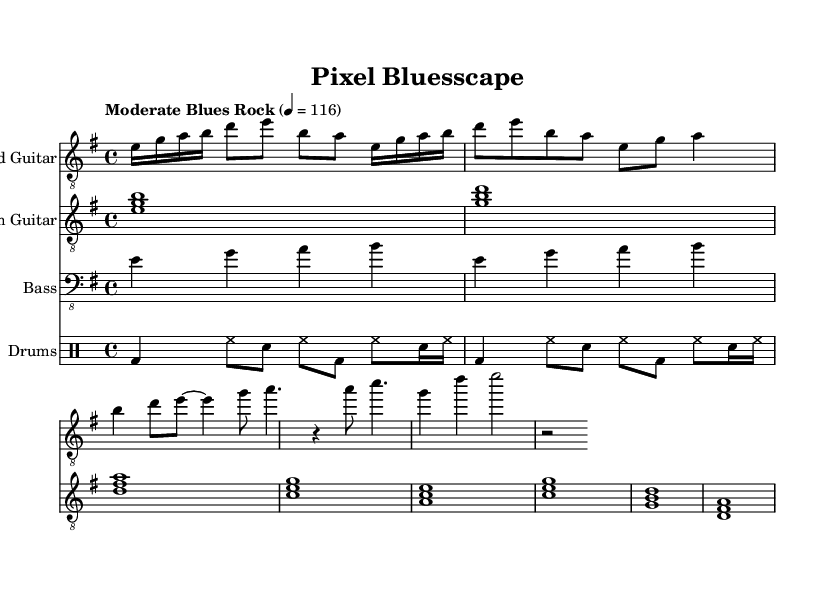What is the key signature of this music? The key signature indicates E minor, which contains one sharp (F#). This is determined by the absence of any flat notes in the staff and following the indicated key at the beginning.
Answer: E minor What is the time signature of this piece? The time signature shown is 4/4, which means there are four beats in a measure and the quarter note receives one beat. This is specified at the beginning of the score.
Answer: 4/4 What is the tempo marking of this composition? The tempo marking states "Moderate Blues Rock," and it indicates a setting of 116 beats per minute, which is noted as a tempo indication right under the global settings.
Answer: Moderate Blues Rock What type of guitar is featured as the lead instrument? The score shows that the clef designated is "treble_8," indicating that this section is for the lead guitar. This is labeled at the beginning of that staff.
Answer: Lead guitar How many measures are there in the verse section of the lead guitar? By reviewing the measures within the lead guitar part, we see that the verse melody section contains a total of four measures, as counted through the notations provided.
Answer: Four measures What is the main chord progression used in the chorus? The chorus progression consists of the following chords: A, C, G, D, which can be identified at the beginning of the chorus melody section in the rhythm guitar part.
Answer: A, C, G, D How is the drum pattern structured? The drum pattern alternates between bass drum (bd), hi-hat (hh), and snare (sn) in a specified rhythm that repeats, indicating a consistent driving beat. The drum section outlines specific rhythmic notations for clarity.
Answer: Alternating pattern 